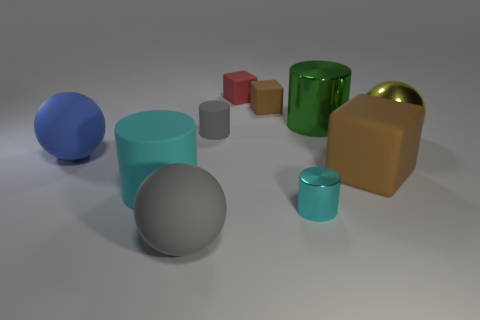Subtract all large brown blocks. How many blocks are left? 2 Subtract all gray spheres. How many spheres are left? 2 Subtract 1 cylinders. How many cylinders are left? 3 Subtract all cubes. How many objects are left? 7 Subtract all red cubes. Subtract all brown cylinders. How many cubes are left? 2 Subtract all purple spheres. How many gray cylinders are left? 1 Subtract all cyan objects. Subtract all rubber cylinders. How many objects are left? 6 Add 1 large blue rubber objects. How many large blue rubber objects are left? 2 Add 3 tiny red things. How many tiny red things exist? 4 Subtract 1 gray spheres. How many objects are left? 9 